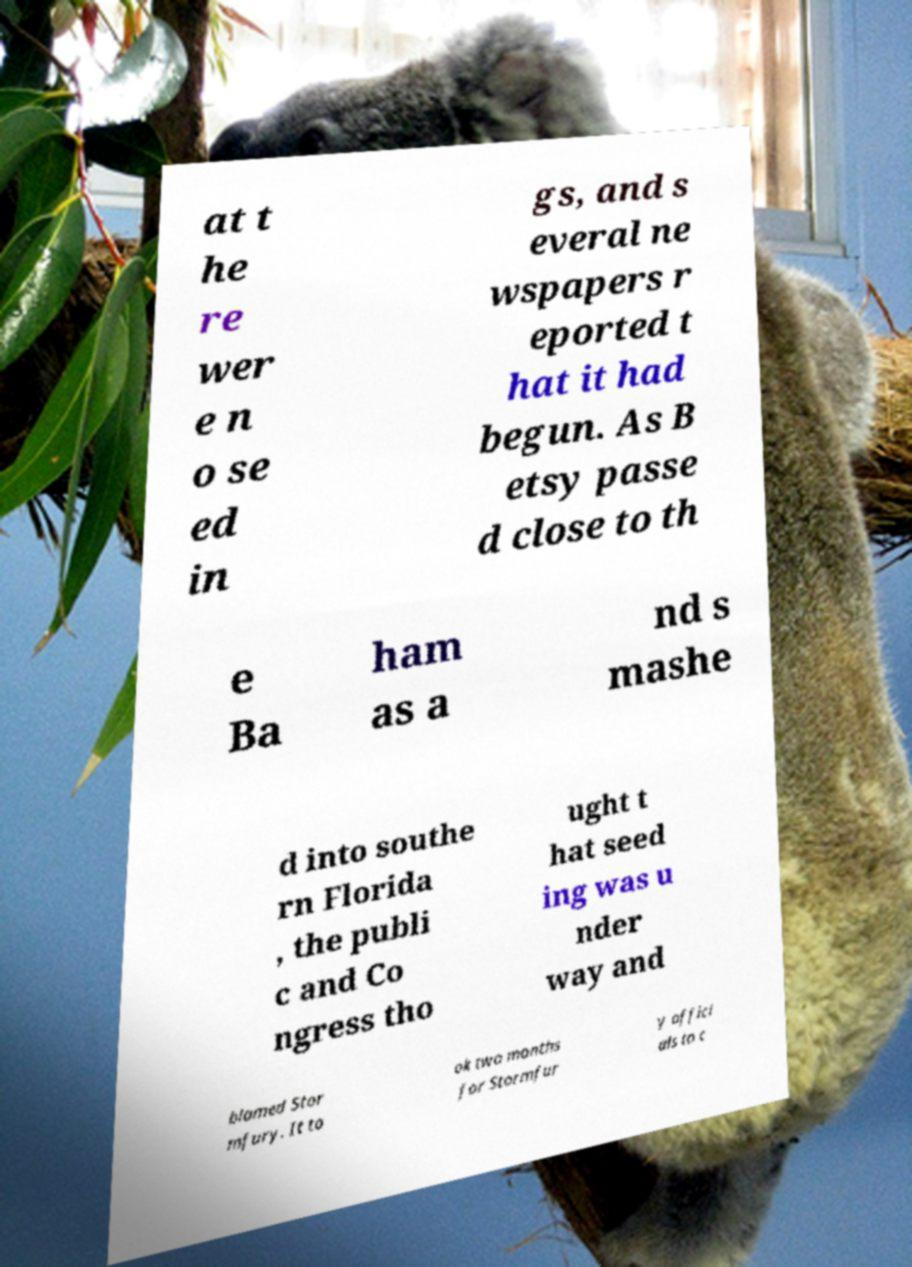Can you accurately transcribe the text from the provided image for me? at t he re wer e n o se ed in gs, and s everal ne wspapers r eported t hat it had begun. As B etsy passe d close to th e Ba ham as a nd s mashe d into southe rn Florida , the publi c and Co ngress tho ught t hat seed ing was u nder way and blamed Stor mfury. It to ok two months for Stormfur y offici als to c 